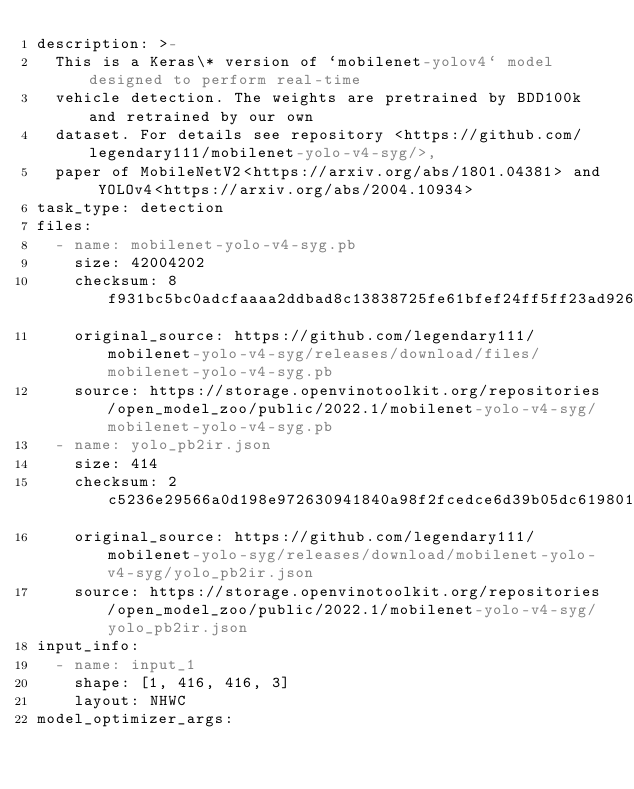<code> <loc_0><loc_0><loc_500><loc_500><_YAML_>description: >-
  This is a Keras\* version of `mobilenet-yolov4` model designed to perform real-time
  vehicle detection. The weights are pretrained by BDD100k and retrained by our own
  dataset. For details see repository <https://github.com/legendary111/mobilenet-yolo-v4-syg/>,
  paper of MobileNetV2<https://arxiv.org/abs/1801.04381> and YOLOv4<https://arxiv.org/abs/2004.10934>
task_type: detection
files:
  - name: mobilenet-yolo-v4-syg.pb
    size: 42004202
    checksum: 8f931bc5bc0adcfaaaa2ddbad8c13838725fe61bfef24ff5ff23ad9268b392c40b3ecb2bbe736152060c7014ced80e6b
    original_source: https://github.com/legendary111/mobilenet-yolo-v4-syg/releases/download/files/mobilenet-yolo-v4-syg.pb
    source: https://storage.openvinotoolkit.org/repositories/open_model_zoo/public/2022.1/mobilenet-yolo-v4-syg/mobilenet-yolo-v4-syg.pb
  - name: yolo_pb2ir.json
    size: 414
    checksum: 2c5236e29566a0d198e972630941840a98f2fcedce6d39b05dc61980166c29a7da9b55883c5dc8b568d682529c18430f
    original_source: https://github.com/legendary111/mobilenet-yolo-syg/releases/download/mobilenet-yolo-v4-syg/yolo_pb2ir.json
    source: https://storage.openvinotoolkit.org/repositories/open_model_zoo/public/2022.1/mobilenet-yolo-v4-syg/yolo_pb2ir.json
input_info:
  - name: input_1
    shape: [1, 416, 416, 3]
    layout: NHWC
model_optimizer_args:</code> 